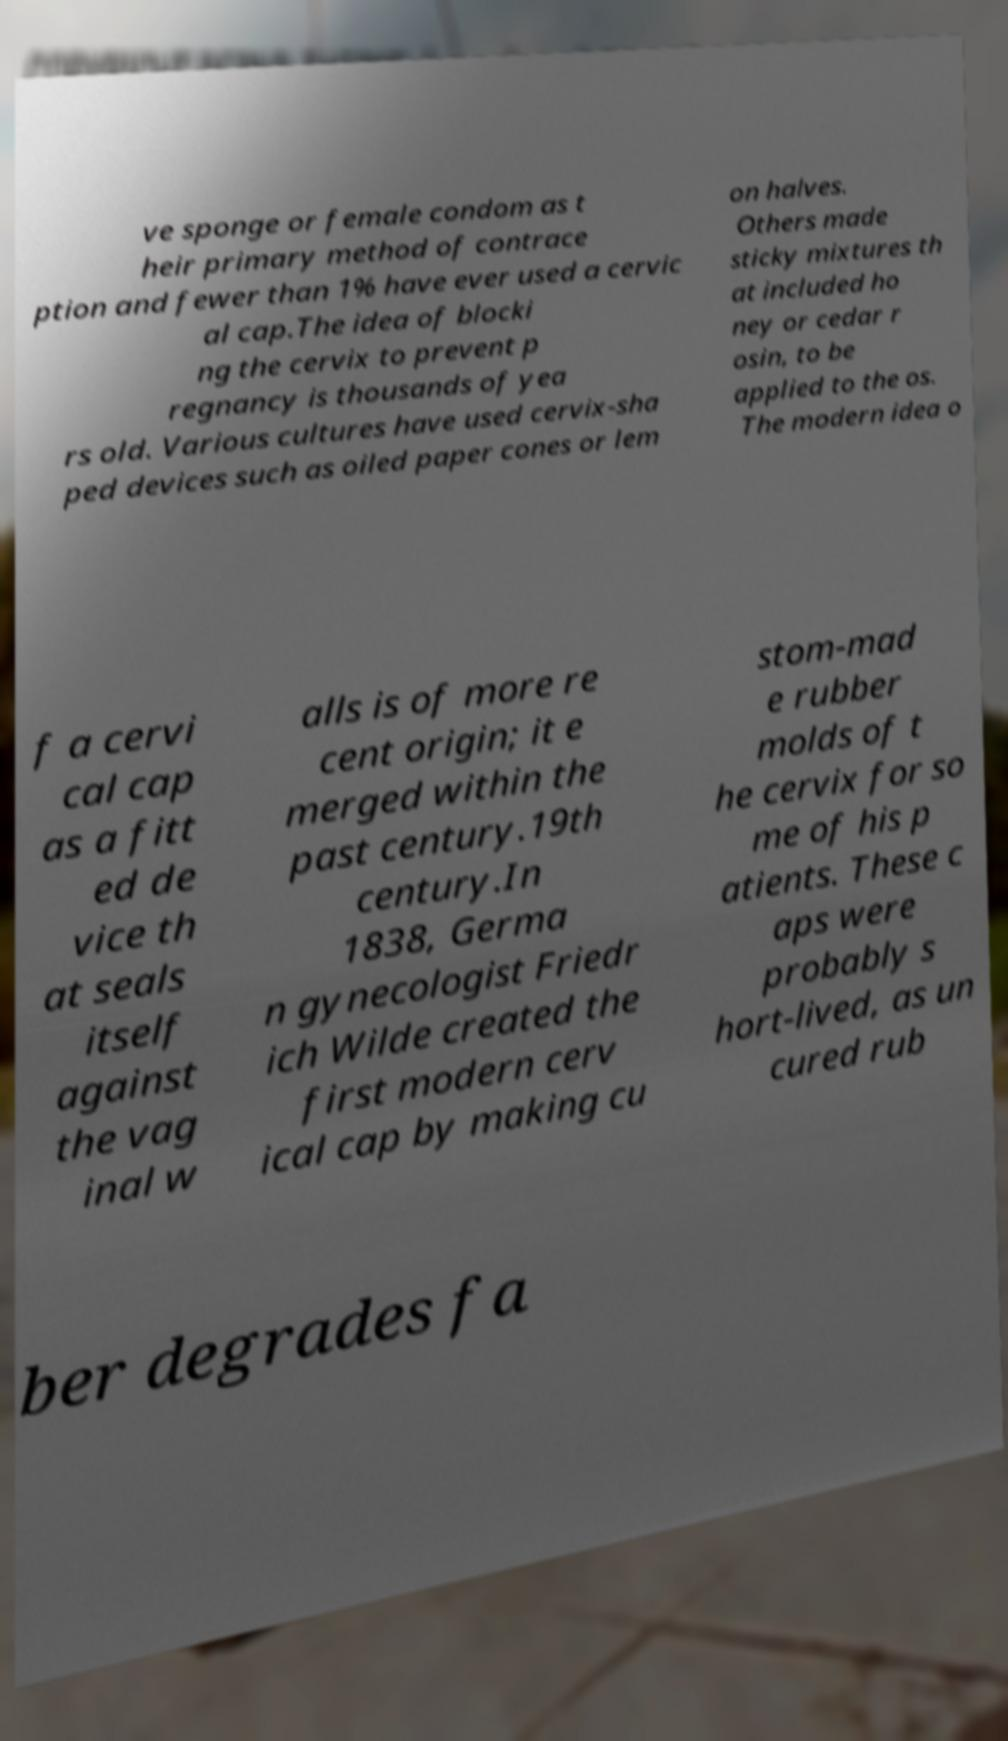Can you read and provide the text displayed in the image?This photo seems to have some interesting text. Can you extract and type it out for me? ve sponge or female condom as t heir primary method of contrace ption and fewer than 1% have ever used a cervic al cap.The idea of blocki ng the cervix to prevent p regnancy is thousands of yea rs old. Various cultures have used cervix-sha ped devices such as oiled paper cones or lem on halves. Others made sticky mixtures th at included ho ney or cedar r osin, to be applied to the os. The modern idea o f a cervi cal cap as a fitt ed de vice th at seals itself against the vag inal w alls is of more re cent origin; it e merged within the past century.19th century.In 1838, Germa n gynecologist Friedr ich Wilde created the first modern cerv ical cap by making cu stom-mad e rubber molds of t he cervix for so me of his p atients. These c aps were probably s hort-lived, as un cured rub ber degrades fa 